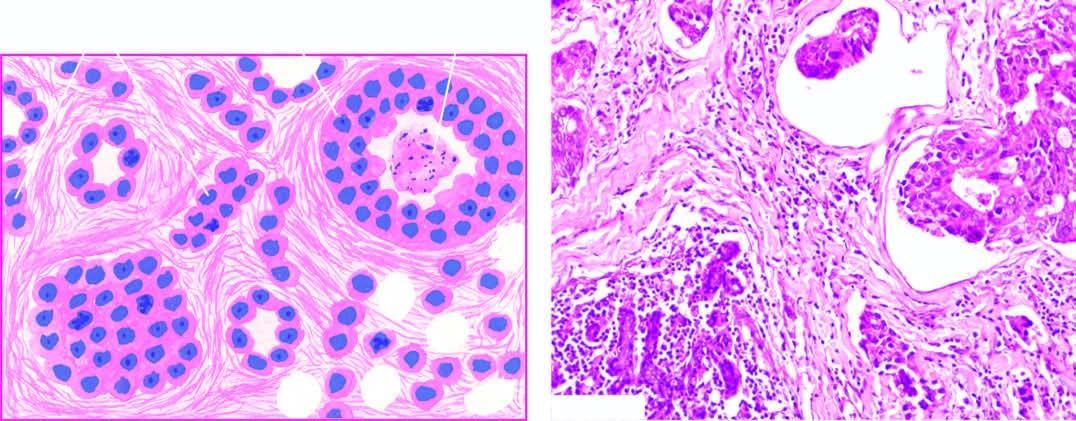what do microscopic features include?
Answer the question using a single word or phrase. Formation of solid nests 